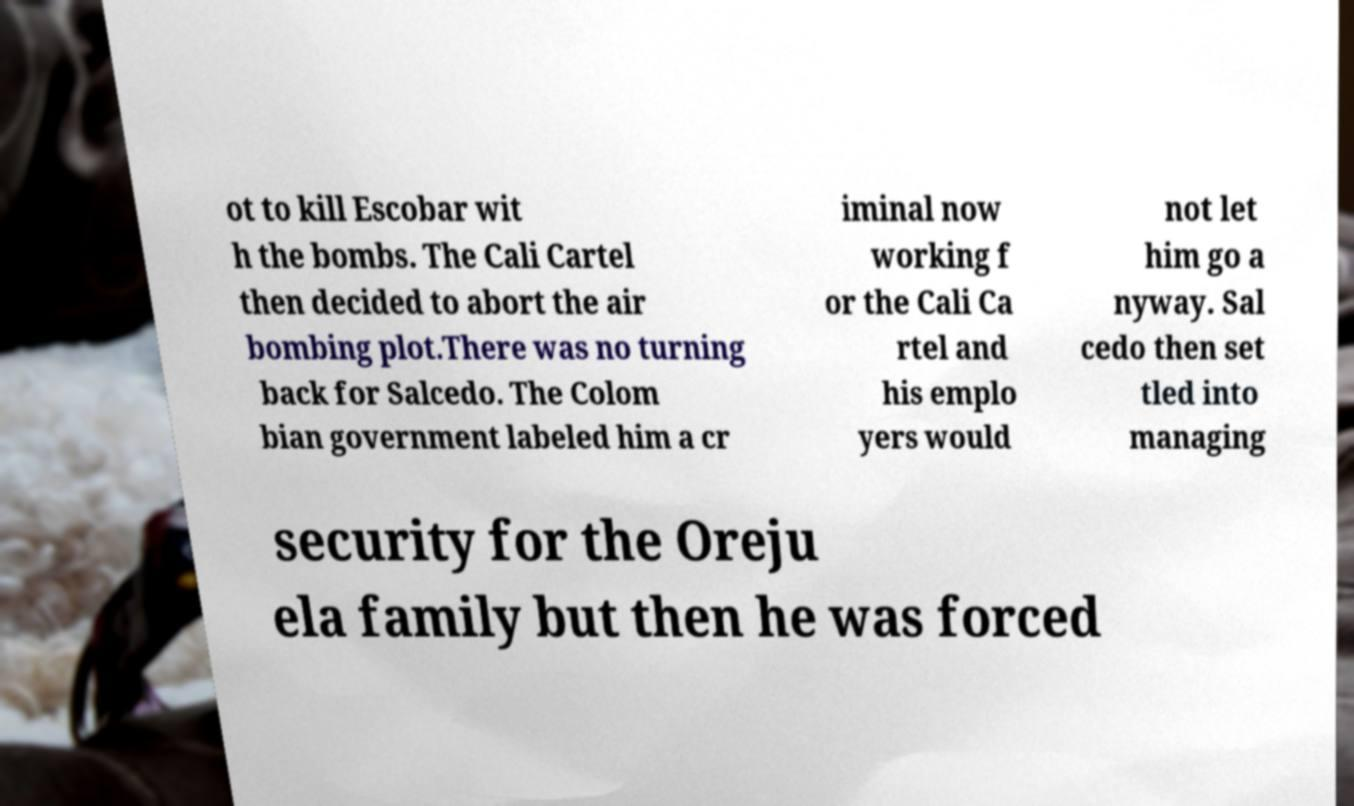Could you extract and type out the text from this image? ot to kill Escobar wit h the bombs. The Cali Cartel then decided to abort the air bombing plot.There was no turning back for Salcedo. The Colom bian government labeled him a cr iminal now working f or the Cali Ca rtel and his emplo yers would not let him go a nyway. Sal cedo then set tled into managing security for the Oreju ela family but then he was forced 